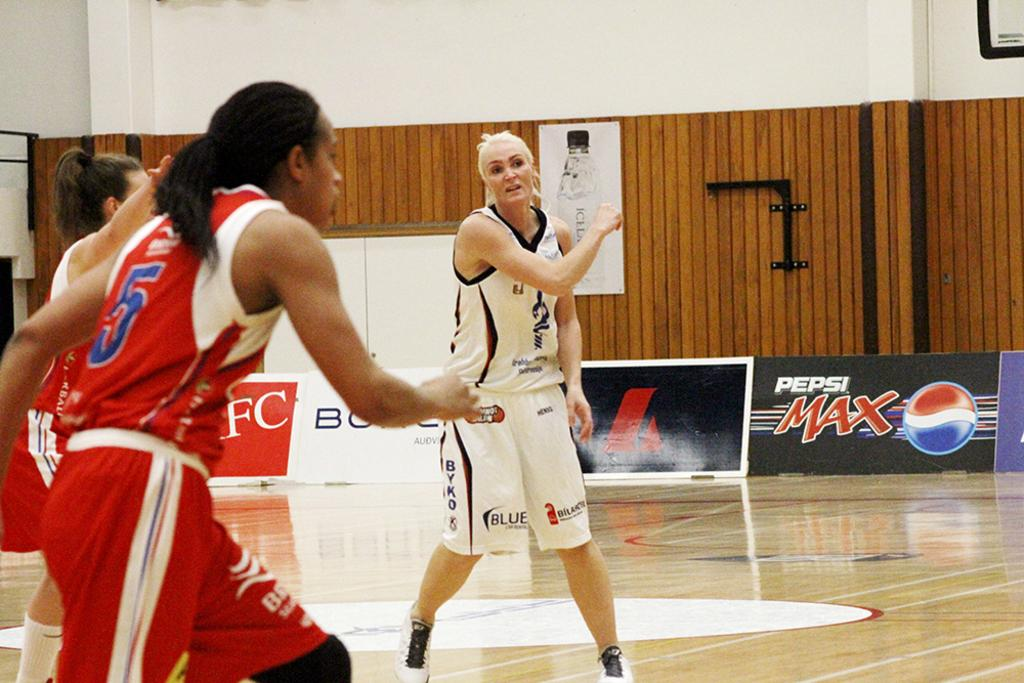<image>
Provide a brief description of the given image. A womens basketball match with a Pepsi Max ad in the back 